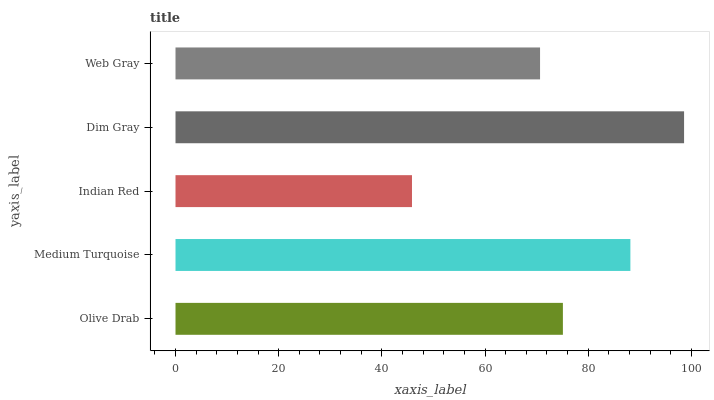Is Indian Red the minimum?
Answer yes or no. Yes. Is Dim Gray the maximum?
Answer yes or no. Yes. Is Medium Turquoise the minimum?
Answer yes or no. No. Is Medium Turquoise the maximum?
Answer yes or no. No. Is Medium Turquoise greater than Olive Drab?
Answer yes or no. Yes. Is Olive Drab less than Medium Turquoise?
Answer yes or no. Yes. Is Olive Drab greater than Medium Turquoise?
Answer yes or no. No. Is Medium Turquoise less than Olive Drab?
Answer yes or no. No. Is Olive Drab the high median?
Answer yes or no. Yes. Is Olive Drab the low median?
Answer yes or no. Yes. Is Medium Turquoise the high median?
Answer yes or no. No. Is Indian Red the low median?
Answer yes or no. No. 